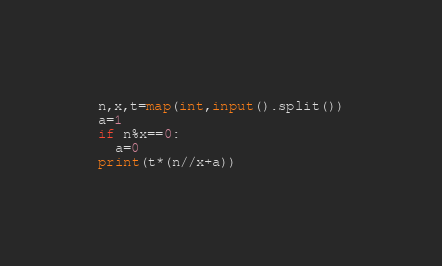Convert code to text. <code><loc_0><loc_0><loc_500><loc_500><_Python_>n,x,t=map(int,input().split())
a=1
if n%x==0:
  a=0
print(t*(n//x+a))
</code> 